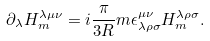Convert formula to latex. <formula><loc_0><loc_0><loc_500><loc_500>\partial _ { \lambda } H _ { m } ^ { \lambda \mu \nu } = i \frac { \pi } { 3 R } m \epsilon _ { \lambda \rho \sigma } ^ { \mu \nu } H _ { m } ^ { \lambda \rho \sigma } .</formula> 